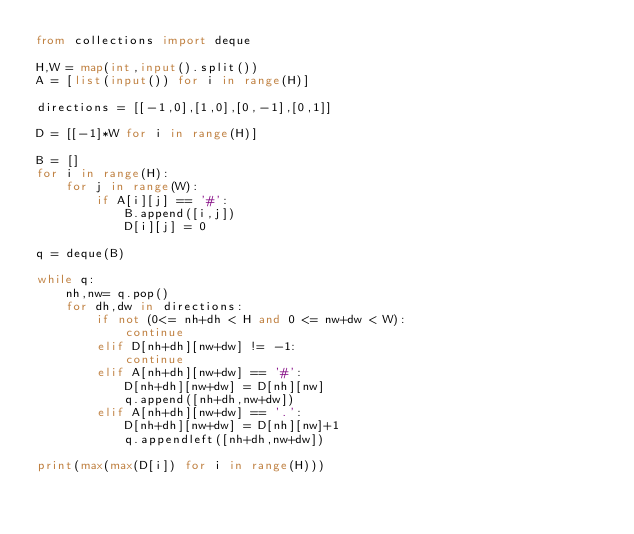Convert code to text. <code><loc_0><loc_0><loc_500><loc_500><_Python_>from collections import deque

H,W = map(int,input().split())
A = [list(input()) for i in range(H)]

directions = [[-1,0],[1,0],[0,-1],[0,1]]

D = [[-1]*W for i in range(H)]

B = []
for i in range(H):
    for j in range(W):
        if A[i][j] == '#':
            B.append([i,j])
            D[i][j] = 0

q = deque(B)

while q:
    nh,nw= q.pop()
    for dh,dw in directions:
        if not (0<= nh+dh < H and 0 <= nw+dw < W):
            continue
        elif D[nh+dh][nw+dw] != -1:
            continue
        elif A[nh+dh][nw+dw] == '#':
            D[nh+dh][nw+dw] = D[nh][nw]
            q.append([nh+dh,nw+dw])
        elif A[nh+dh][nw+dw] == '.':
            D[nh+dh][nw+dw] = D[nh][nw]+1
            q.appendleft([nh+dh,nw+dw])

print(max(max(D[i]) for i in range(H)))</code> 